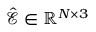Convert formula to latex. <formula><loc_0><loc_0><loc_500><loc_500>\hat { \mathcal { E } } \in \mathbb { R } ^ { N \times 3 }</formula> 